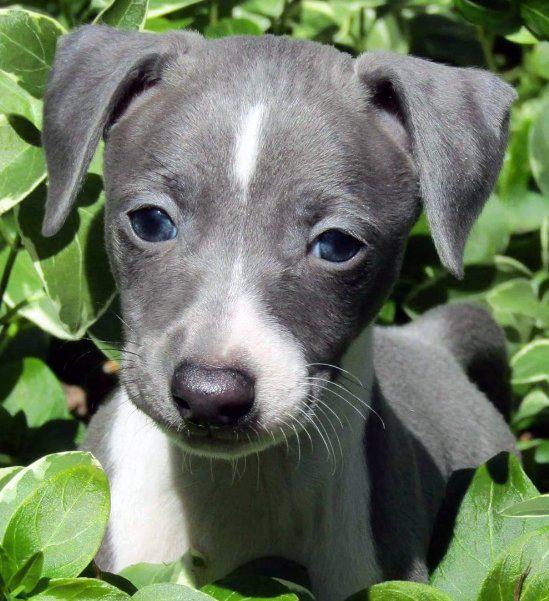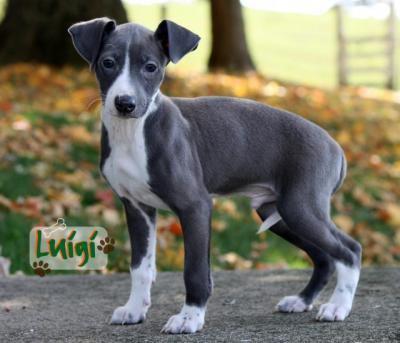The first image is the image on the left, the second image is the image on the right. Given the left and right images, does the statement "All four feet of the dog in the image on the right can be seen touching the ground." hold true? Answer yes or no. Yes. 